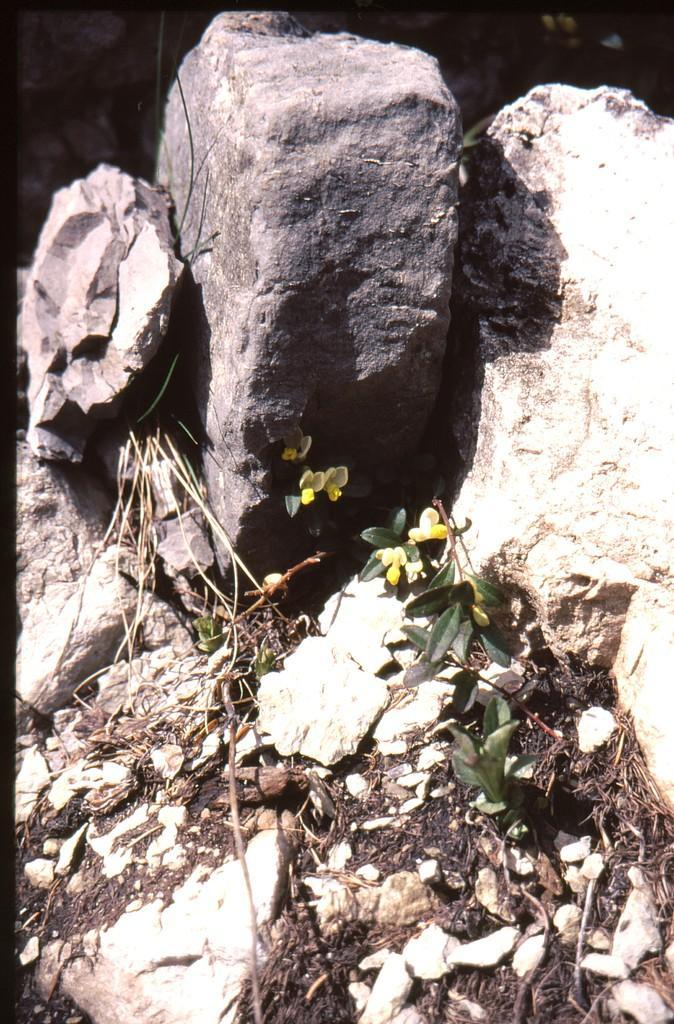How would you summarize this image in a sentence or two? In this image there are rocks. There are plants, dried stems and dried leaves on the rocks. At the top it is dark. 